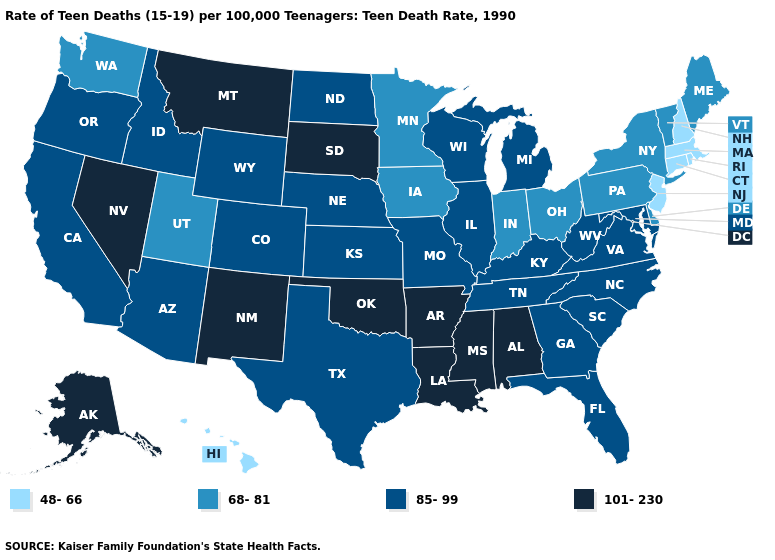Which states have the highest value in the USA?
Quick response, please. Alabama, Alaska, Arkansas, Louisiana, Mississippi, Montana, Nevada, New Mexico, Oklahoma, South Dakota. Among the states that border Kentucky , which have the highest value?
Answer briefly. Illinois, Missouri, Tennessee, Virginia, West Virginia. Name the states that have a value in the range 85-99?
Keep it brief. Arizona, California, Colorado, Florida, Georgia, Idaho, Illinois, Kansas, Kentucky, Maryland, Michigan, Missouri, Nebraska, North Carolina, North Dakota, Oregon, South Carolina, Tennessee, Texas, Virginia, West Virginia, Wisconsin, Wyoming. Does Texas have the lowest value in the South?
Short answer required. No. What is the value of New Hampshire?
Give a very brief answer. 48-66. What is the highest value in states that border Wyoming?
Write a very short answer. 101-230. What is the lowest value in states that border Louisiana?
Quick response, please. 85-99. What is the value of Wyoming?
Write a very short answer. 85-99. Which states have the highest value in the USA?
Answer briefly. Alabama, Alaska, Arkansas, Louisiana, Mississippi, Montana, Nevada, New Mexico, Oklahoma, South Dakota. Does Minnesota have a higher value than Connecticut?
Short answer required. Yes. What is the value of Wisconsin?
Answer briefly. 85-99. Does Alaska have the highest value in the USA?
Write a very short answer. Yes. What is the value of Massachusetts?
Keep it brief. 48-66. Among the states that border Ohio , which have the highest value?
Be succinct. Kentucky, Michigan, West Virginia. 